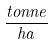<formula> <loc_0><loc_0><loc_500><loc_500>\frac { t o n n e } { h a }</formula> 